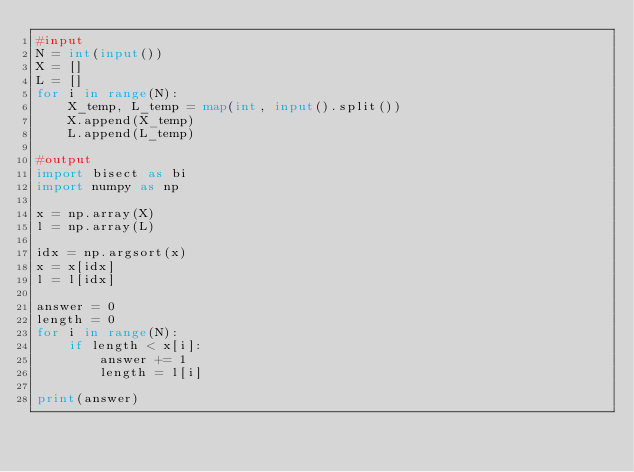<code> <loc_0><loc_0><loc_500><loc_500><_Python_>#input
N = int(input())
X = []
L = []
for i in range(N):
    X_temp, L_temp = map(int, input().split())
    X.append(X_temp)
    L.append(L_temp)

#output
import bisect as bi
import numpy as np

x = np.array(X)
l = np.array(L)

idx = np.argsort(x)
x = x[idx]
l = l[idx]

answer = 0
length = 0
for i in range(N):
    if length < x[i]:
        answer += 1
        length = l[i]

print(answer)</code> 